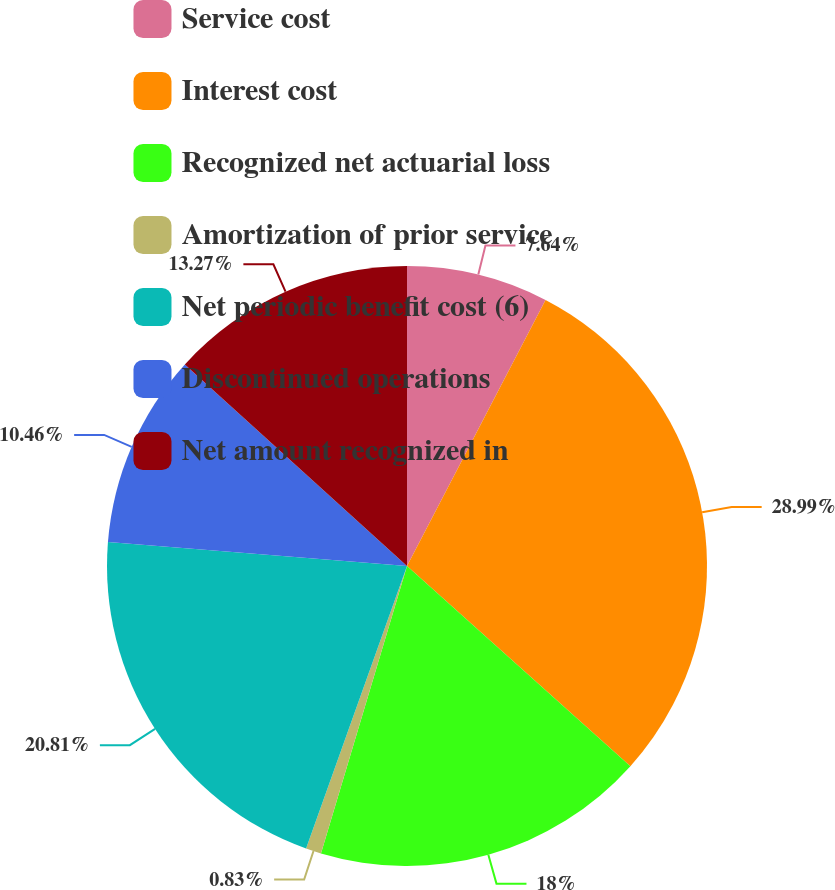Convert chart. <chart><loc_0><loc_0><loc_500><loc_500><pie_chart><fcel>Service cost<fcel>Interest cost<fcel>Recognized net actuarial loss<fcel>Amortization of prior service<fcel>Net periodic benefit cost (6)<fcel>Discontinued operations<fcel>Net amount recognized in<nl><fcel>7.64%<fcel>28.99%<fcel>18.0%<fcel>0.83%<fcel>20.81%<fcel>10.46%<fcel>13.27%<nl></chart> 